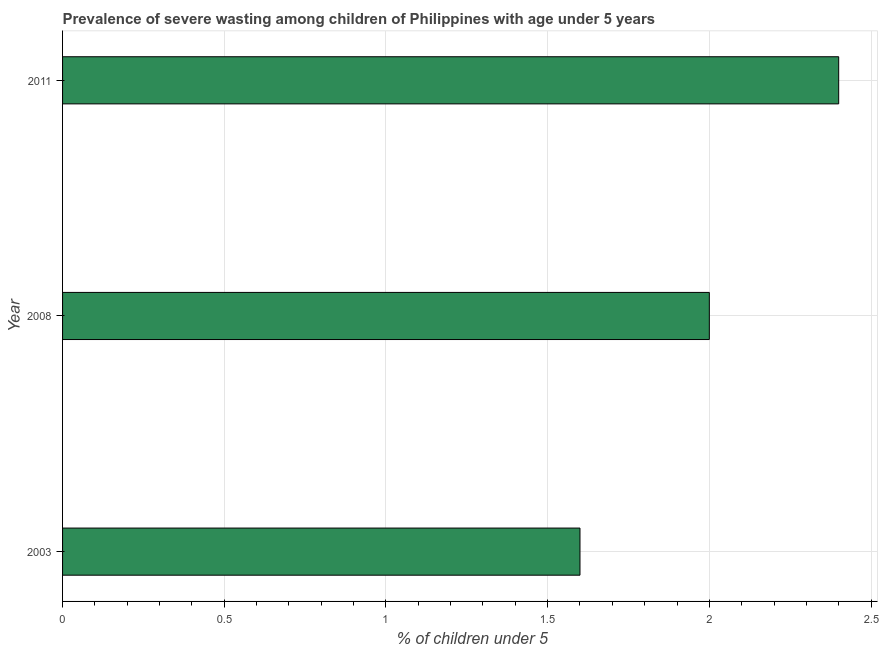Does the graph contain grids?
Keep it short and to the point. Yes. What is the title of the graph?
Your response must be concise. Prevalence of severe wasting among children of Philippines with age under 5 years. What is the label or title of the X-axis?
Keep it short and to the point.  % of children under 5. What is the prevalence of severe wasting in 2011?
Make the answer very short. 2.4. Across all years, what is the maximum prevalence of severe wasting?
Offer a very short reply. 2.4. Across all years, what is the minimum prevalence of severe wasting?
Your response must be concise. 1.6. What is the sum of the prevalence of severe wasting?
Give a very brief answer. 6. What is the difference between the prevalence of severe wasting in 2003 and 2008?
Offer a very short reply. -0.4. In how many years, is the prevalence of severe wasting greater than 1.8 %?
Offer a very short reply. 2. What is the ratio of the prevalence of severe wasting in 2003 to that in 2008?
Make the answer very short. 0.8. Are all the bars in the graph horizontal?
Provide a short and direct response. Yes. What is the  % of children under 5 in 2003?
Offer a terse response. 1.6. What is the  % of children under 5 of 2008?
Offer a terse response. 2. What is the  % of children under 5 in 2011?
Make the answer very short. 2.4. What is the difference between the  % of children under 5 in 2008 and 2011?
Your answer should be compact. -0.4. What is the ratio of the  % of children under 5 in 2003 to that in 2011?
Your answer should be compact. 0.67. What is the ratio of the  % of children under 5 in 2008 to that in 2011?
Provide a succinct answer. 0.83. 